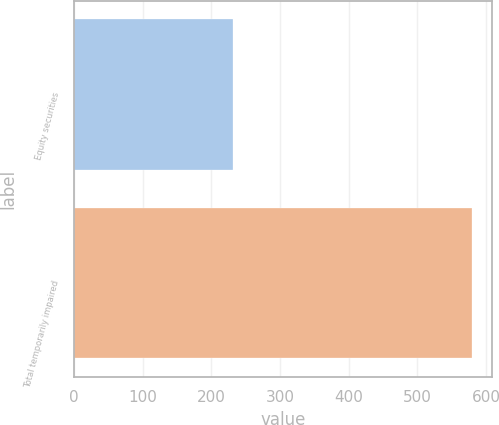Convert chart to OTSL. <chart><loc_0><loc_0><loc_500><loc_500><bar_chart><fcel>Equity securities<fcel>Total temporarily impaired<nl><fcel>231<fcel>580<nl></chart> 